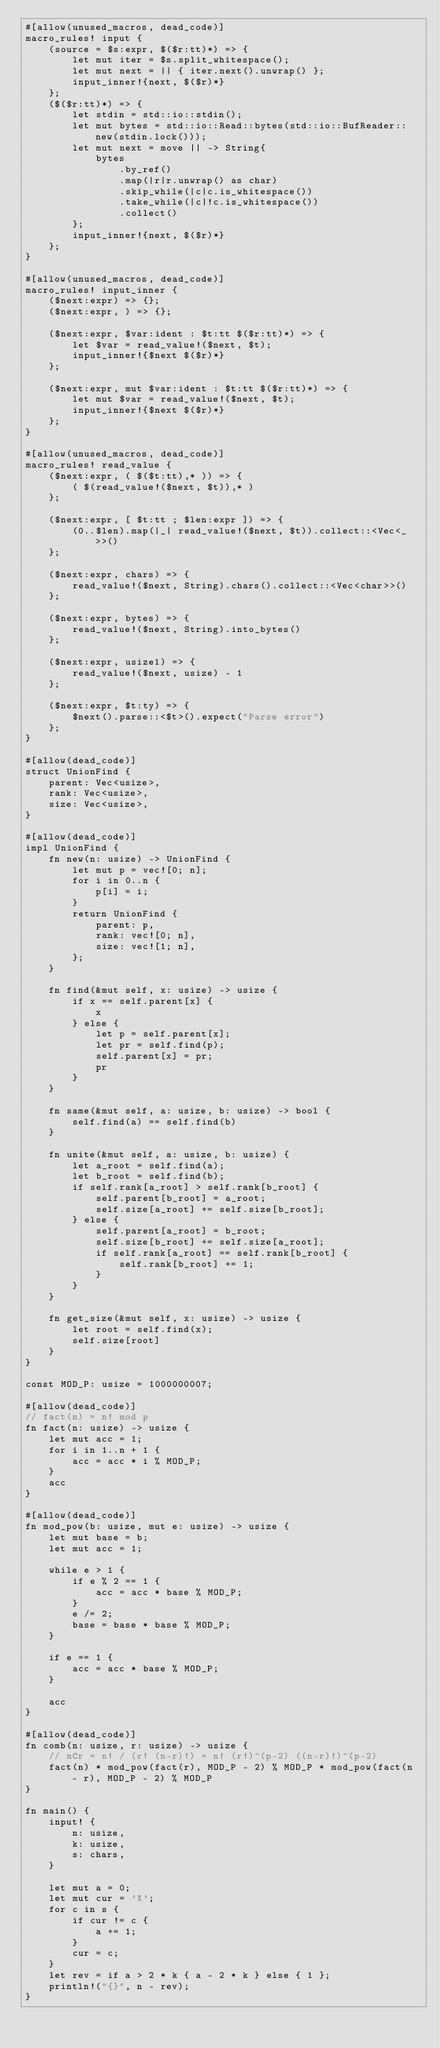<code> <loc_0><loc_0><loc_500><loc_500><_Rust_>#[allow(unused_macros, dead_code)]
macro_rules! input {
    (source = $s:expr, $($r:tt)*) => {
        let mut iter = $s.split_whitespace();
        let mut next = || { iter.next().unwrap() };
        input_inner!{next, $($r)*}
    };
    ($($r:tt)*) => {
        let stdin = std::io::stdin();
        let mut bytes = std::io::Read::bytes(std::io::BufReader::new(stdin.lock()));
        let mut next = move || -> String{
            bytes
                .by_ref()
                .map(|r|r.unwrap() as char)
                .skip_while(|c|c.is_whitespace())
                .take_while(|c|!c.is_whitespace())
                .collect()
        };
        input_inner!{next, $($r)*}
    };
}

#[allow(unused_macros, dead_code)]
macro_rules! input_inner {
    ($next:expr) => {};
    ($next:expr, ) => {};

    ($next:expr, $var:ident : $t:tt $($r:tt)*) => {
        let $var = read_value!($next, $t);
        input_inner!{$next $($r)*}
    };

    ($next:expr, mut $var:ident : $t:tt $($r:tt)*) => {
        let mut $var = read_value!($next, $t);
        input_inner!{$next $($r)*}
    };
}

#[allow(unused_macros, dead_code)]
macro_rules! read_value {
    ($next:expr, ( $($t:tt),* )) => {
        ( $(read_value!($next, $t)),* )
    };

    ($next:expr, [ $t:tt ; $len:expr ]) => {
        (0..$len).map(|_| read_value!($next, $t)).collect::<Vec<_>>()
    };

    ($next:expr, chars) => {
        read_value!($next, String).chars().collect::<Vec<char>>()
    };

    ($next:expr, bytes) => {
        read_value!($next, String).into_bytes()
    };

    ($next:expr, usize1) => {
        read_value!($next, usize) - 1
    };

    ($next:expr, $t:ty) => {
        $next().parse::<$t>().expect("Parse error")
    };
}

#[allow(dead_code)]
struct UnionFind {
    parent: Vec<usize>,
    rank: Vec<usize>,
    size: Vec<usize>,
}

#[allow(dead_code)]
impl UnionFind {
    fn new(n: usize) -> UnionFind {
        let mut p = vec![0; n];
        for i in 0..n {
            p[i] = i;
        }
        return UnionFind {
            parent: p,
            rank: vec![0; n],
            size: vec![1; n],
        };
    }

    fn find(&mut self, x: usize) -> usize {
        if x == self.parent[x] {
            x
        } else {
            let p = self.parent[x];
            let pr = self.find(p);
            self.parent[x] = pr;
            pr
        }
    }

    fn same(&mut self, a: usize, b: usize) -> bool {
        self.find(a) == self.find(b)
    }

    fn unite(&mut self, a: usize, b: usize) {
        let a_root = self.find(a);
        let b_root = self.find(b);
        if self.rank[a_root] > self.rank[b_root] {
            self.parent[b_root] = a_root;
            self.size[a_root] += self.size[b_root];
        } else {
            self.parent[a_root] = b_root;
            self.size[b_root] += self.size[a_root];
            if self.rank[a_root] == self.rank[b_root] {
                self.rank[b_root] += 1;
            }
        }
    }

    fn get_size(&mut self, x: usize) -> usize {
        let root = self.find(x);
        self.size[root]
    }
}

const MOD_P: usize = 1000000007;

#[allow(dead_code)]
// fact(n) = n! mod p
fn fact(n: usize) -> usize {
    let mut acc = 1;
    for i in 1..n + 1 {
        acc = acc * i % MOD_P;
    }
    acc
}

#[allow(dead_code)]
fn mod_pow(b: usize, mut e: usize) -> usize {
    let mut base = b;
    let mut acc = 1;

    while e > 1 {
        if e % 2 == 1 {
            acc = acc * base % MOD_P;
        }
        e /= 2;
        base = base * base % MOD_P;
    }

    if e == 1 {
        acc = acc * base % MOD_P;
    }

    acc
}

#[allow(dead_code)]
fn comb(n: usize, r: usize) -> usize {
    // nCr = n! / (r! (n-r)!) = n! (r!)^(p-2) ((n-r)!)^(p-2)
    fact(n) * mod_pow(fact(r), MOD_P - 2) % MOD_P * mod_pow(fact(n - r), MOD_P - 2) % MOD_P
}

fn main() {
    input! {
        n: usize,
        k: usize,
        s: chars,
    }

    let mut a = 0;
    let mut cur = 'X';
    for c in s {
        if cur != c {
            a += 1;
        }
        cur = c;
    }
    let rev = if a > 2 * k { a - 2 * k } else { 1 };
    println!("{}", n - rev);
}
</code> 